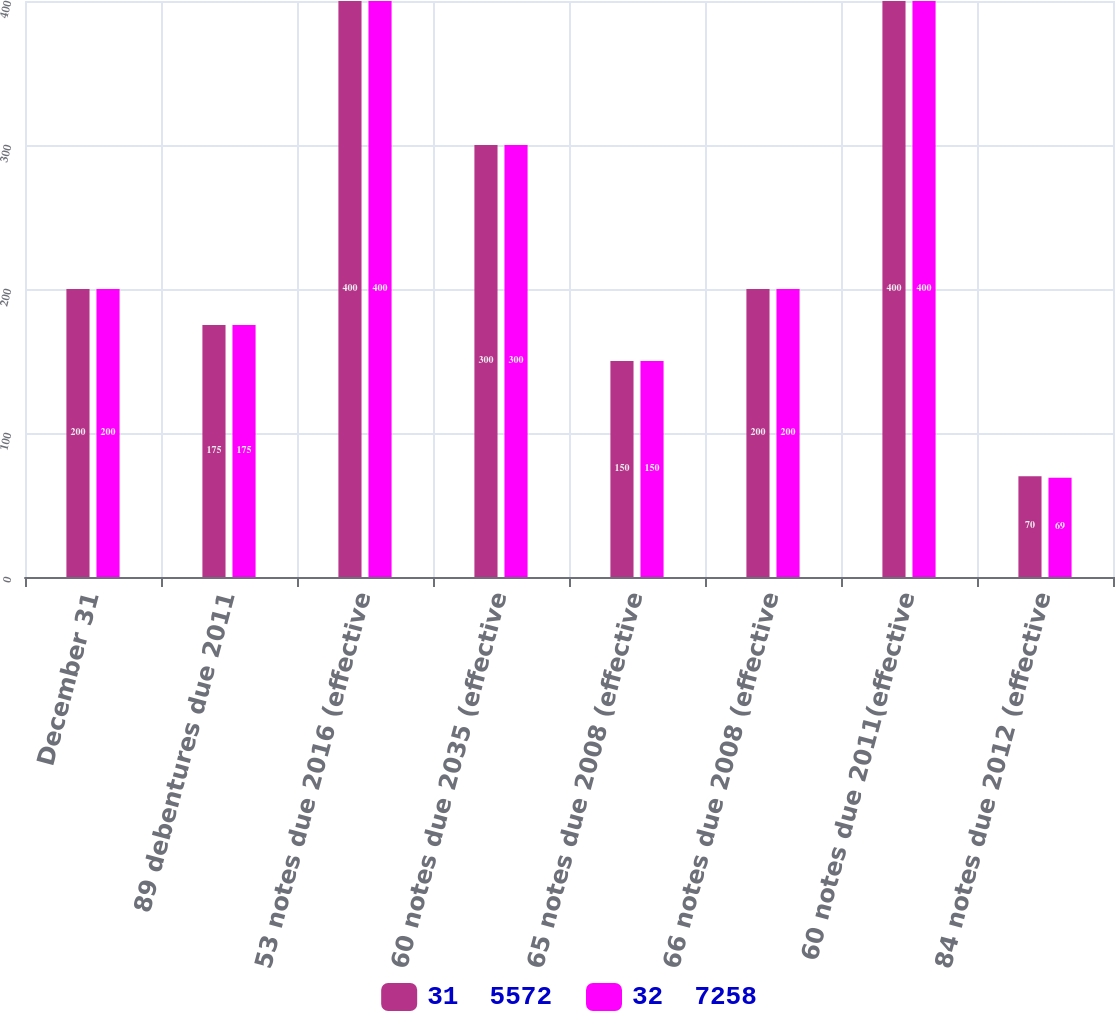Convert chart. <chart><loc_0><loc_0><loc_500><loc_500><stacked_bar_chart><ecel><fcel>December 31<fcel>89 debentures due 2011<fcel>53 notes due 2016 (effective<fcel>60 notes due 2035 (effective<fcel>65 notes due 2008 (effective<fcel>66 notes due 2008 (effective<fcel>60 notes due 2011(effective<fcel>84 notes due 2012 (effective<nl><fcel>31  5572<fcel>200<fcel>175<fcel>400<fcel>300<fcel>150<fcel>200<fcel>400<fcel>70<nl><fcel>32  7258<fcel>200<fcel>175<fcel>400<fcel>300<fcel>150<fcel>200<fcel>400<fcel>69<nl></chart> 